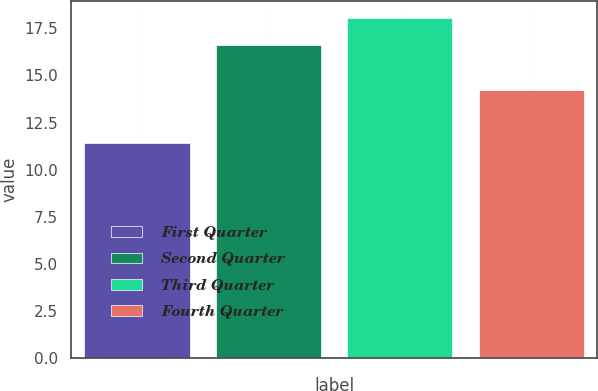Convert chart to OTSL. <chart><loc_0><loc_0><loc_500><loc_500><bar_chart><fcel>First Quarter<fcel>Second Quarter<fcel>Third Quarter<fcel>Fourth Quarter<nl><fcel>11.44<fcel>16.6<fcel>18.05<fcel>14.24<nl></chart> 